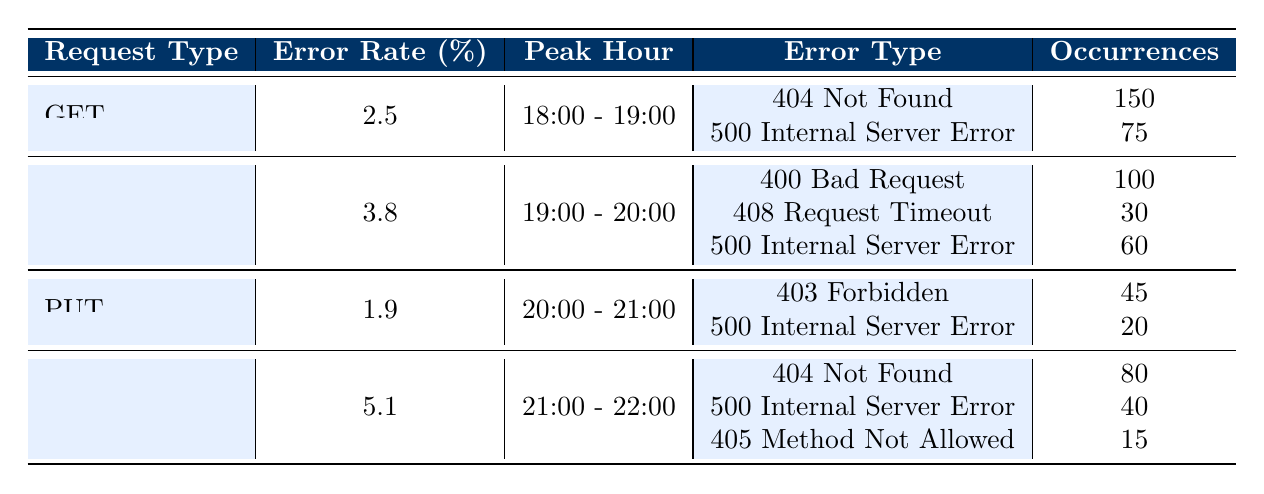What is the error rate percentage for the POST request type? The table shows that the error rate percentage for the POST request type is explicitly listed in the second row, which is 3.8%.
Answer: 3.8% During which peak hour does the highest error rate occur? The DELETE request type has the highest error rate of 5.1%, occurring during the peak hour of 21:00 - 22:00. The peak hour listed for all request types allows us to compare and identify this as the highest rate.
Answer: 21:00 - 22:00 How many occurrences of "404 Not Found" errors are reported for the GET request type? Referring to the GET request section in the table, we see that there are 150 occurrences of "404 Not Found".
Answer: 150 What is the total number of error occurrences for all request types combined? To calculate the total, we sum the occurrences for each error type across all request types: 150 (GET) + 75 (GET) + 100 (POST) + 30 (POST) + 60 (POST) + 45 (PUT) + 20 (PUT) + 80 (DELETE) + 40 (DELETE) + 15 (DELETE) = 615.
Answer: 615 Is the error rate for the PUT request type higher than 2%? The error rate listed for the PUT request type is 1.9%, which is lower than 2%. Thus, the statement is false.
Answer: No Which request type has the maximum occurrences for the error "500 Internal Server Error"? The error occurrences for "500 Internal Server Error" for each request type are: 75 (GET), 60 (POST), 20 (PUT), and 40 (DELETE). Comparing these, the GET request type has the highest occurrences of 75.
Answer: GET If we consider only errors with occurrences above 40, how many errors fall into this category? From the table, the errors with occurrences above 40 are: 150 (404 Not Found for GET), 75 (500 Internal Server Error for GET), 100 (400 Bad Request for POST), 60 (500 Internal Server Error for POST), 80 (404 Not Found for DELETE), 40 (500 Internal Server Error for DELETE). Counting these gives us 6 occurrences that surpass the threshold of 40.
Answer: 6 What is the difference in error rate percentage between the POST and PUT request types? The error rate percentage for POST is 3.8% and for PUT is 1.9%. The difference is calculated by subtracting the PUT error rate from the POST error rate: 3.8 - 1.9 = 1.9.
Answer: 1.9 